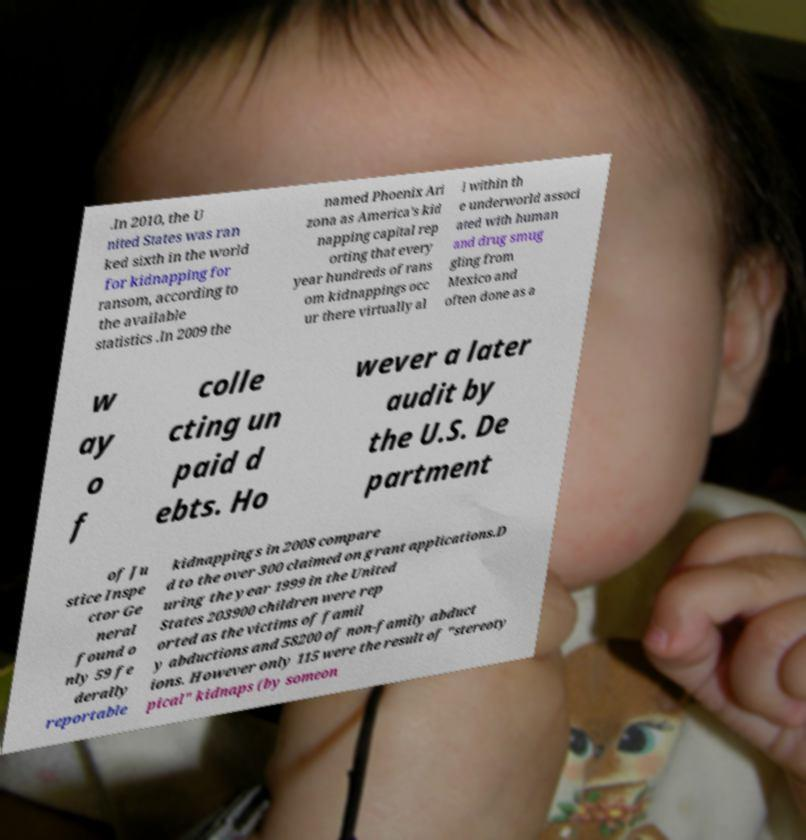Could you extract and type out the text from this image? .In 2010, the U nited States was ran ked sixth in the world for kidnapping for ransom, according to the available statistics .In 2009 the named Phoenix Ari zona as America's kid napping capital rep orting that every year hundreds of rans om kidnappings occ ur there virtually al l within th e underworld associ ated with human and drug smug gling from Mexico and often done as a w ay o f colle cting un paid d ebts. Ho wever a later audit by the U.S. De partment of Ju stice Inspe ctor Ge neral found o nly 59 fe derally reportable kidnappings in 2008 compare d to the over 300 claimed on grant applications.D uring the year 1999 in the United States 203900 children were rep orted as the victims of famil y abductions and 58200 of non-family abduct ions. However only 115 were the result of "stereoty pical" kidnaps (by someon 